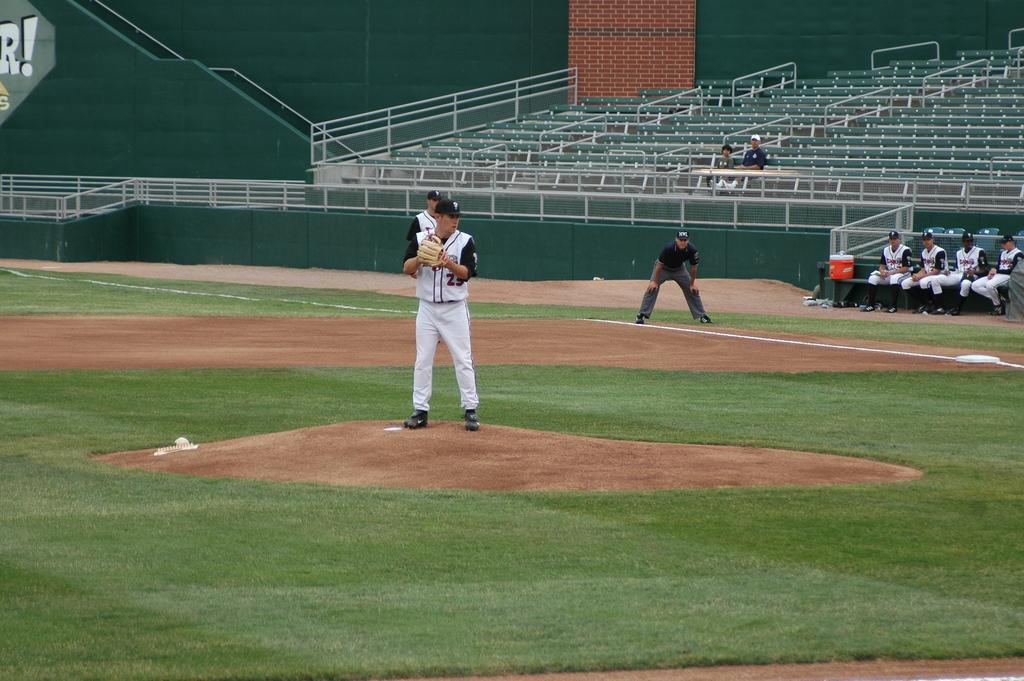How many people are in the image? There are people in the image, but the exact number is not specified. What are the people in the image doing? Some people are standing on the ground, while others are sitting. What can be seen in the background of the image? There is a stadium in the background of the image, and it has seats. What else is visible in the background? There is a wall visible in the background. What type of division is taking place in the image? There is no division taking place in the image. Can you tell me which downtown area the image is depicting? The facts provided do not mention any specific downtown area, so it cannot be determined from the image. 